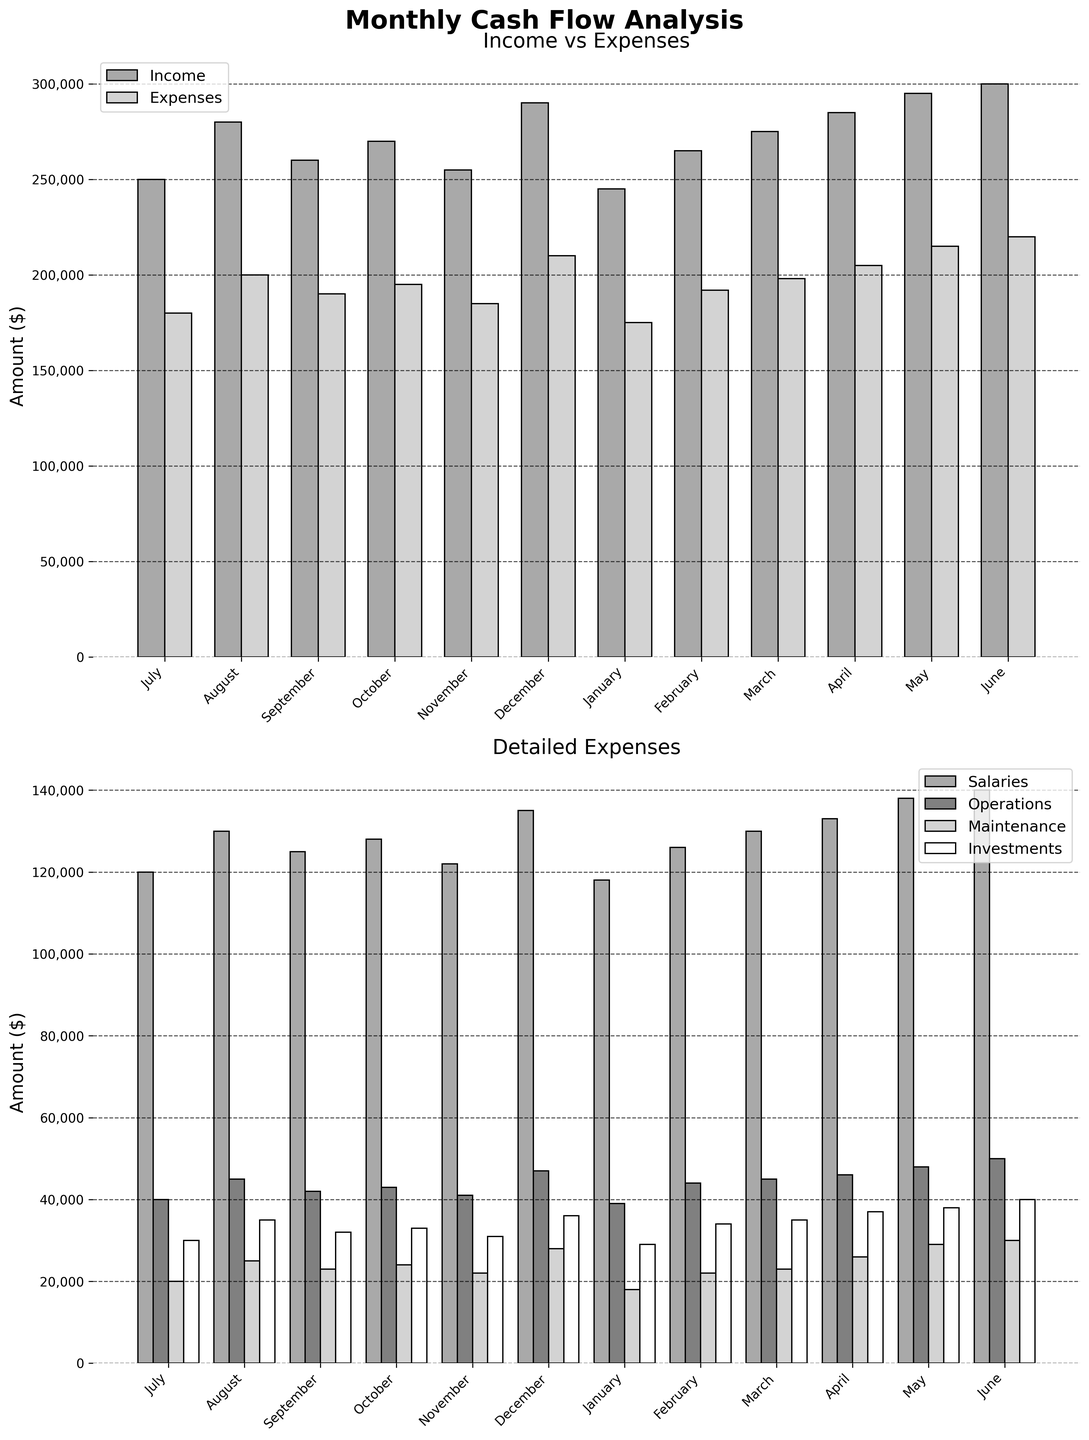What is the title of the top subplot? The title of the top subplot can be found above the subplot itself, usually styled in larger and bold text compared to other labels. Here it reads "Income vs Expenses".
Answer: Income vs Expenses Which month has the highest income? The highest income can be identified by observing the bar that reaches the highest point under the 'Income' category on the top subplot. The longest bar in the 'Income' category corresponds to June.
Answer: June What are the axis labels of the bottom subplot? The axis labels are the descriptions next to the axes of the bottom subplot. For the y-axis, it reads "Amount ($)", and the x-axis represents months given as categories.
Answer: Amount ($), Month What is the total value of expenses in December? The total value of expenses for December can be found by locating the December bars in both subplots and adding all expense components. In December: Salaries (135,000) + Operations (47,000) + Maintenance (28,000) + Investments (36,000) = 246,000.
Answer: 246,000 Compare the incomes of January and June. Which is greater and by how much? The incomes for January and June can be directly noted from the height of the bars under 'Income' on the top subplot. January's income is 245,000, and June's is 300,000. The difference is 300,000 - 245,000 = 55,000.
Answer: June by 55,000 What proportion of October's expenses is for Salaries? To find the proportion of Salaries in October's expenses, we divide the Salaries in October by the total expenses for October. Expenses: 195,000; Salaries: 128,000. The proportion = (128,000 / 195,000) ≈ 0.656.
Answer: 65.6% Which category has the smallest variance in values over the months: Operations or Maintenance? To determine variance, observe the range of bar heights for Operations and Maintenance in the bottom subplot. The heights of Operations bars vary more compared to the more consistent heights of the Maintenance bars, indicating smaller variance in Maintenance.
Answer: Maintenance By how much did the total expenses change from July to August? The change in total expenses is calculated by subtracting the total expenses of July from August. August: 200,000; July: 180,000. The change = 200,000 - 180,000 = 20,000.
Answer: 20,000 What is the average investment value over all months? To find the average, sum the investment values for each month, then divide by the number of months. Sum: 30,000 + 35,000 + 32,000 + 33,000 + 31,000 + 36,000 + 29,000 + 34,000 + 35,000 + 37,000 + 38,000 + 40,000 = 410,000; Average = 410,000 / 12 = 34,167.
Answer: 34,167 